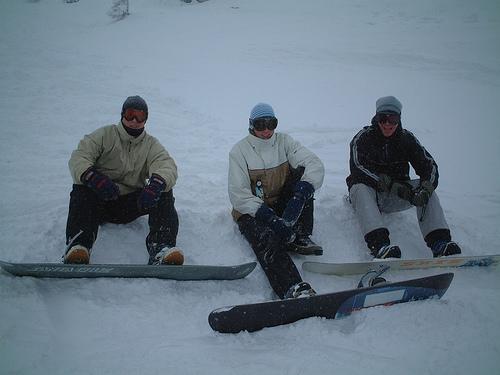What color is the middle persons hat?
Quick response, please. Blue. How many feet aren't on a board?
Concise answer only. 1. How many people are there?
Write a very short answer. 3. 